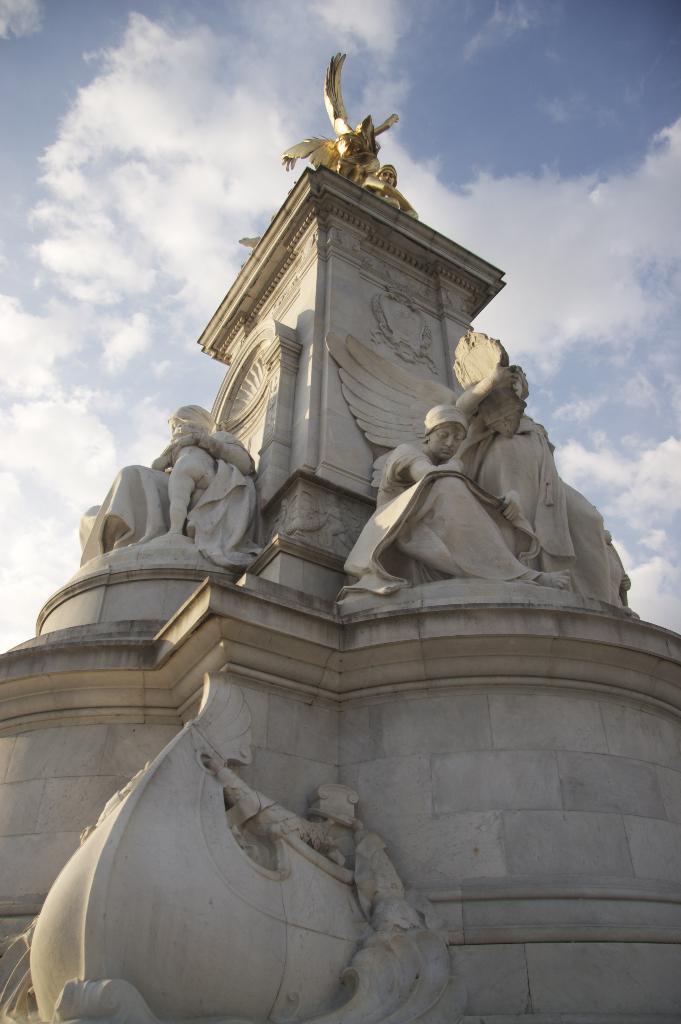In one or two sentences, can you explain what this image depicts? In this picture we can see statues, wall and in the background we can see the sky with clouds. 